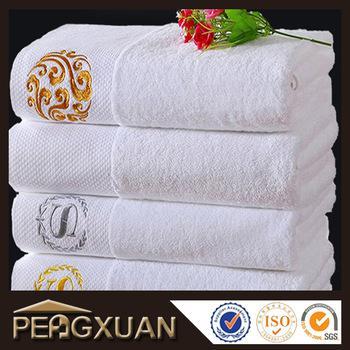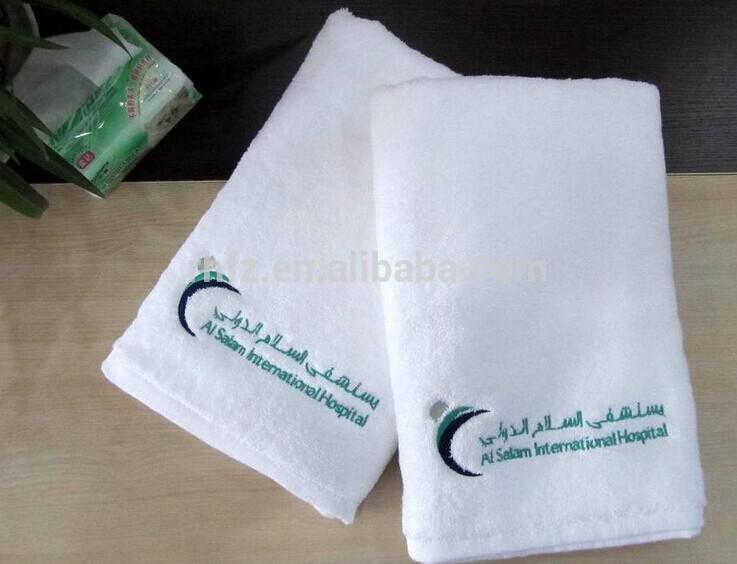The first image is the image on the left, the second image is the image on the right. For the images shown, is this caption "The left image shows three white towels with the Sheraton logo stacked on top of each other." true? Answer yes or no. No. The first image is the image on the left, the second image is the image on the right. Analyze the images presented: Is the assertion "In one of the images, four towels are stacked in a single stack." valid? Answer yes or no. Yes. 